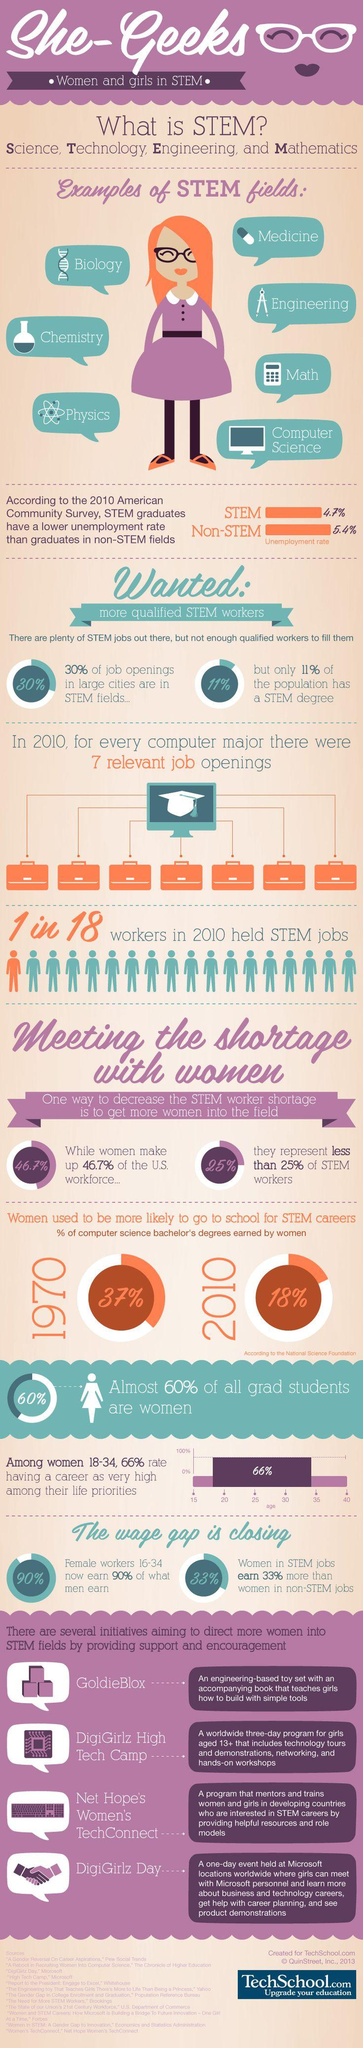Give some essential details in this illustration. In 2010, a significant percentage of women chose to upskill and pursue careers in STEM fields. According to statistics, 37%, 18%, or 60% of women upskilled themselves to take up a STEM career, with the highest percentage being 18%. A recent study found that only 21.7% of women choose to pursue careers in STEM fields, compared to other career options. 